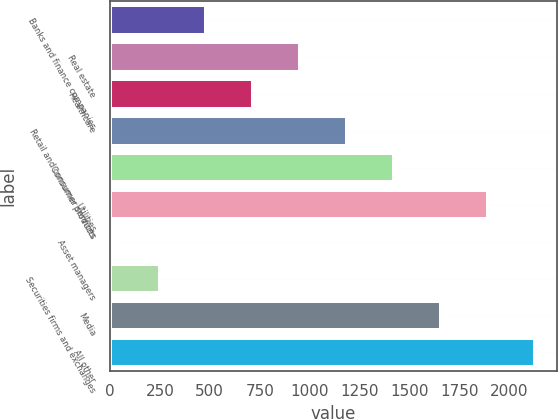<chart> <loc_0><loc_0><loc_500><loc_500><bar_chart><fcel>Banks and finance companies<fcel>Real estate<fcel>Healthcare<fcel>Retail and consumer services<fcel>Consumer products<fcel>Utilities<fcel>Asset managers<fcel>Securities firms and exchanges<fcel>Media<fcel>All other<nl><fcel>483.4<fcel>953.8<fcel>718.6<fcel>1189<fcel>1424.2<fcel>1894.6<fcel>13<fcel>248.2<fcel>1659.4<fcel>2129.8<nl></chart> 